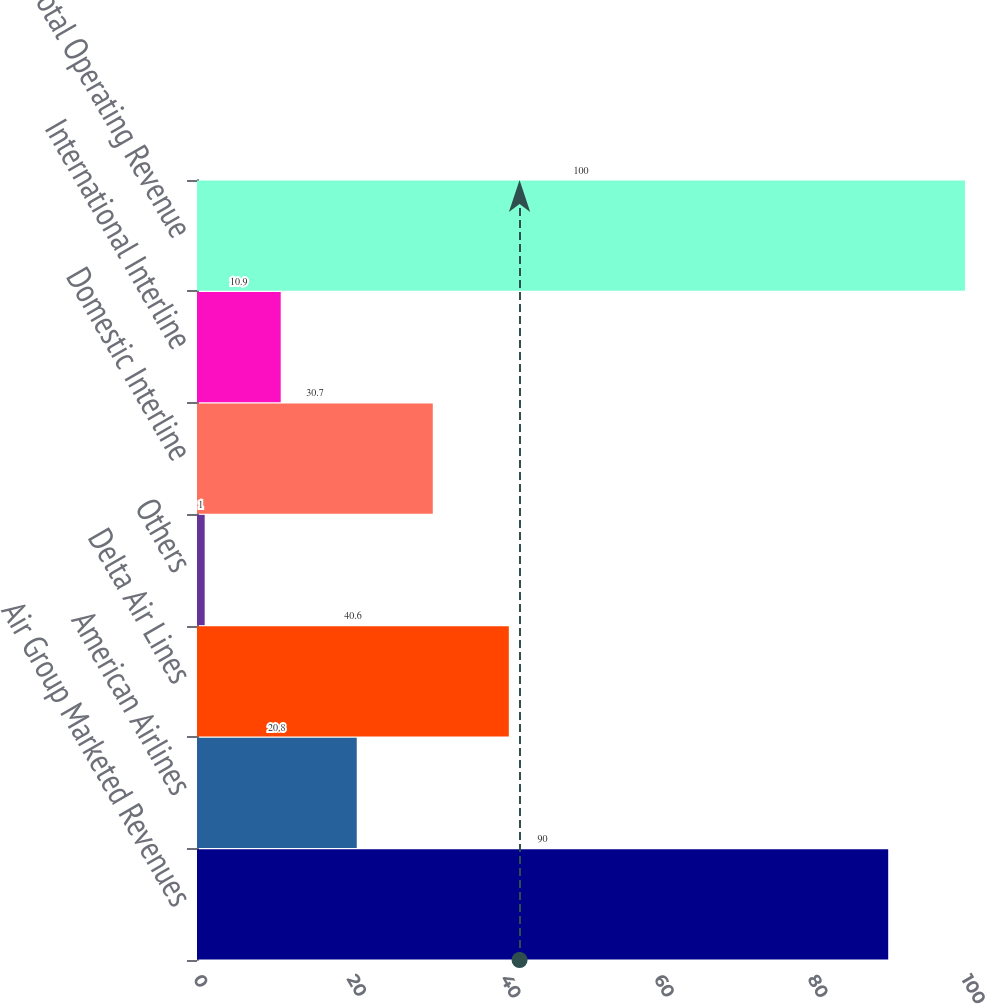<chart> <loc_0><loc_0><loc_500><loc_500><bar_chart><fcel>Air Group Marketed Revenues<fcel>American Airlines<fcel>Delta Air Lines<fcel>Others<fcel>Domestic Interline<fcel>International Interline<fcel>Total Operating Revenue<nl><fcel>90<fcel>20.8<fcel>40.6<fcel>1<fcel>30.7<fcel>10.9<fcel>100<nl></chart> 